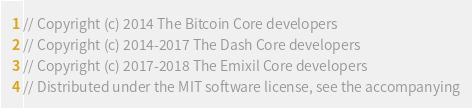Convert code to text. <code><loc_0><loc_0><loc_500><loc_500><_C_>// Copyright (c) 2014 The Bitcoin Core developers
// Copyright (c) 2014-2017 The Dash Core developers
// Copyright (c) 2017-2018 The Emixil Core developers
// Distributed under the MIT software license, see the accompanying</code> 